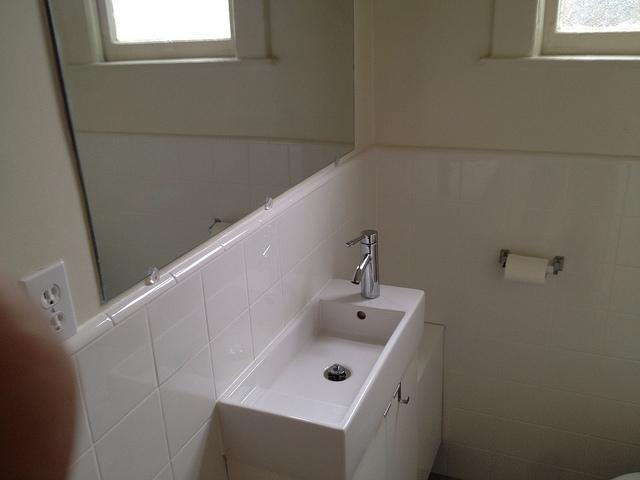How many outlets are there?
Give a very brief answer. 1. 